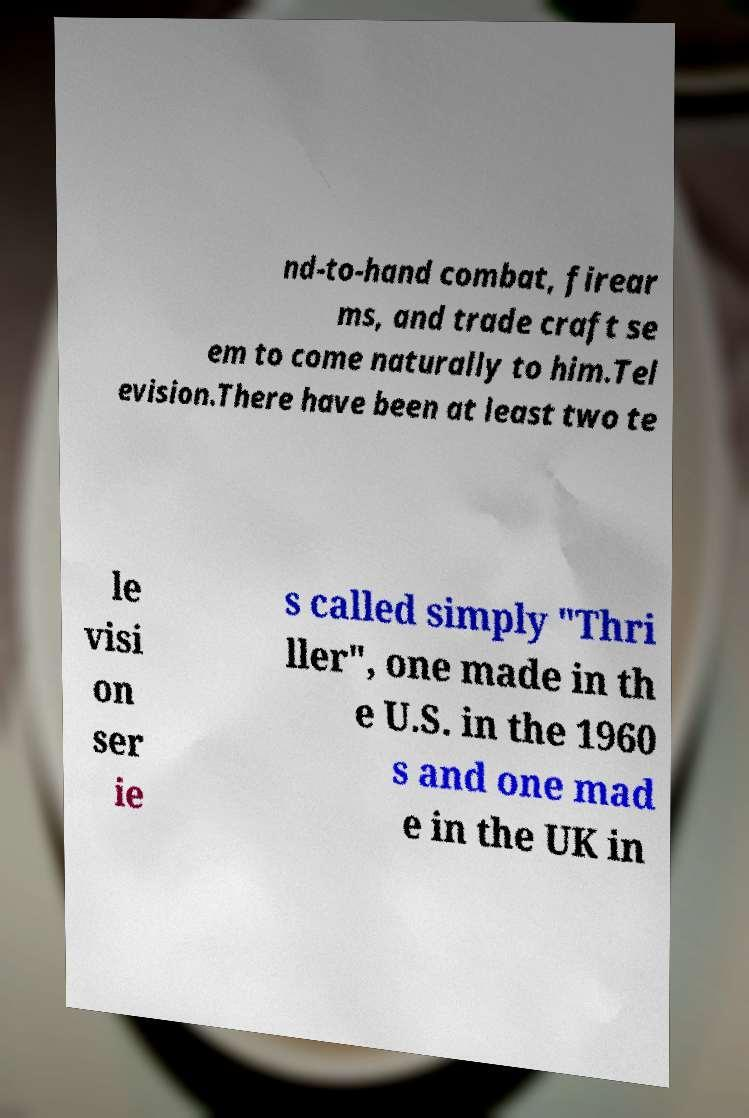Can you accurately transcribe the text from the provided image for me? nd-to-hand combat, firear ms, and trade craft se em to come naturally to him.Tel evision.There have been at least two te le visi on ser ie s called simply "Thri ller", one made in th e U.S. in the 1960 s and one mad e in the UK in 